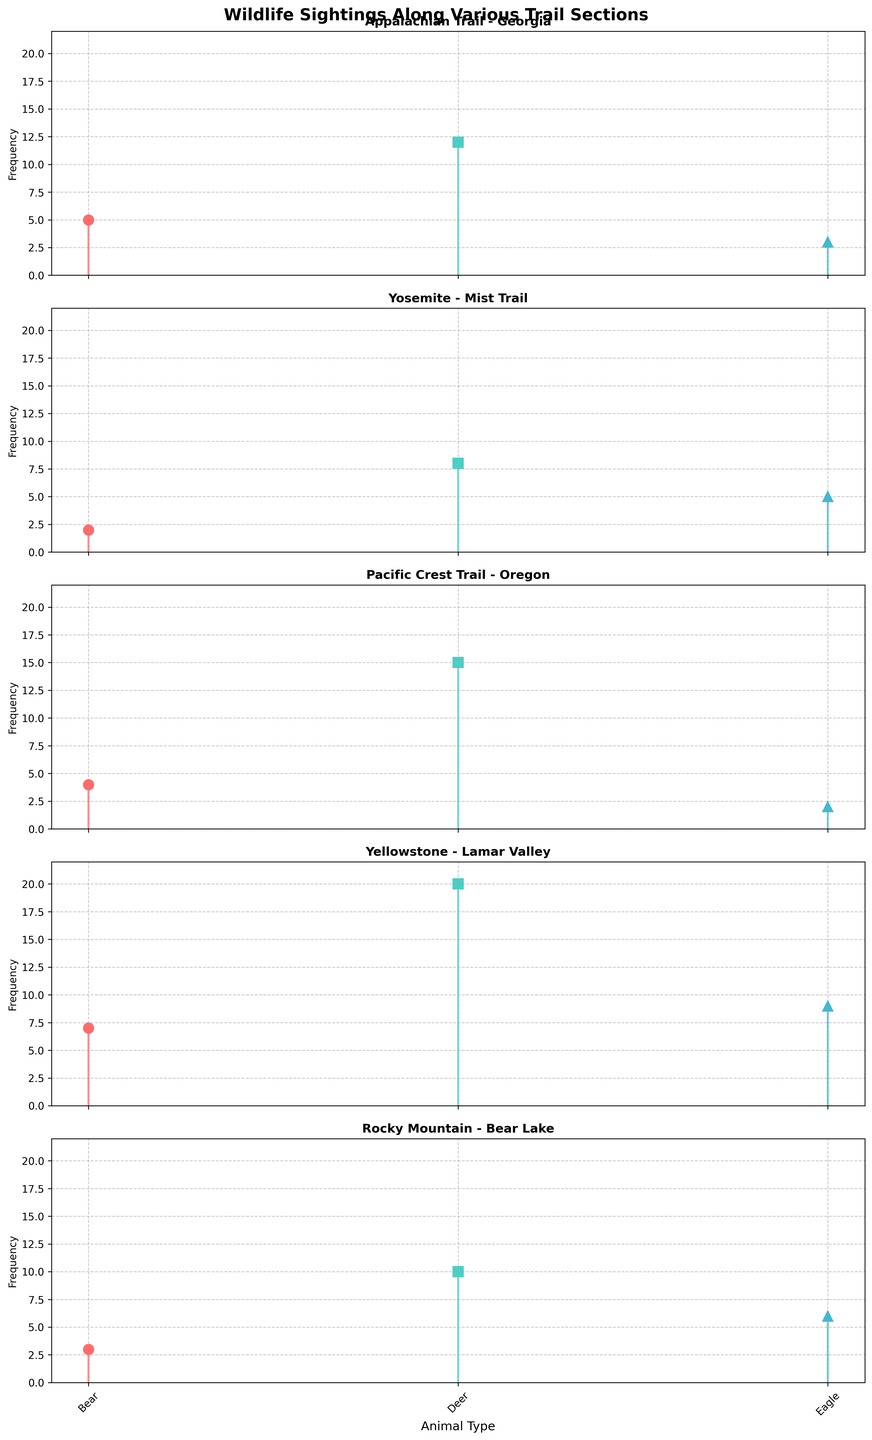How many bears were sighted in the Appalachian Trail - Georgia section? Look at the stem plot for the Appalachian Trail - Georgia section and count the number of stem points labeled “Bear.”
Answer: 5 Which trail section has the highest number of eagle sightings? Compare the stem heights of eagle sightings across all trail sections to find the highest one.
Answer: Yellowstone - Lamar Valley What is the total number of deer sightings across all trail sections? Sum the deer sightings from each trail section: 12 (Appalachian Trail - Georgia) + 8 (Yosemite - Mist Trail) + 15 (Pacific Crest Trail - Oregon) + 20 (Yellowstone - Lamar Valley) + 10 (Rocky Mountain - Bear Lake) = 65
Answer: 65 How many types of animals are plotted for each trail section? Count the different markers (representing different animal types) on each subplot.
Answer: 3 In which trail section were bears sighted least frequently? Identify the stem plot with the shortest height for the bear marker.
Answer: Yosemite - Mist Trail What is the average frequency of bear sightings across all trail sections? Sum the bear sightings and divide by the number of trail sections: (5 + 2 + 4 + 7 + 3) / 5 = 21 / 5
Answer: 4.2 Which trail section has the highest total frequency of wildlife sightings? Sum the frequencies of all animal sightings in each trail section and compare them: 
Appalachian Trail - Georgia (5+12+3), Yosemite – Mist Trail (2+8+5), Pacific Crest Trail – Oregon (4+15+2), Yellowstone – Lamar Valley (7+20+9), Rocky Mountain – Bear Lake (3+10+6)
Answer: Yellowstone - Lamar Valley How does the number of deer sightings in the Pacific Crest Trail - Oregon section compare to the bear sightings in the same section? Compare the stem heights labeled “Deer” and “Bear” for the Pacific Crest Trail - Oregon section.
Answer: Deer sightings are higher Which animal was sighted the most in the Rocky Mountain - Bear Lake section? Look at the stems for the Rocky Mountain - Bear Lake section and identify the highest marker.
Answer: Deer Is the number of eagle sightings in Yosemite - Mist Trail greater than that in Rocky Mountain - Bear Lake? Compare the stem heights for eagle sightings between Yosemite - Mist Trail (5) and Rocky Mountain - Bear Lake (6).
Answer: No 